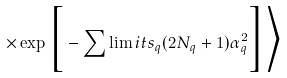Convert formula to latex. <formula><loc_0><loc_0><loc_500><loc_500>\times \exp { \Big [ - \sum \lim i t s _ { q } { ( 2 N _ { q } + 1 ) \alpha _ { q } ^ { 2 } } \Big ] } \Big \rangle</formula> 